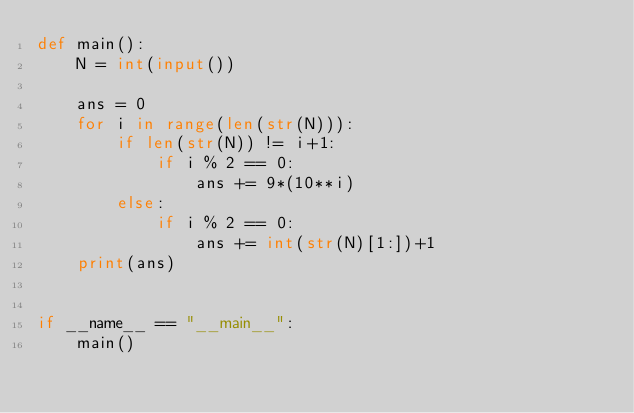<code> <loc_0><loc_0><loc_500><loc_500><_Python_>def main():
    N = int(input())

    ans = 0
    for i in range(len(str(N))):
        if len(str(N)) != i+1:
            if i % 2 == 0:
                ans += 9*(10**i)
        else:
            if i % 2 == 0:
                ans += int(str(N)[1:])+1
    print(ans)


if __name__ == "__main__":
    main()</code> 